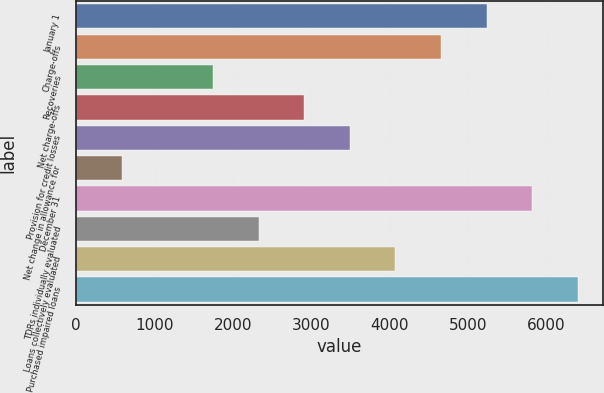Convert chart to OTSL. <chart><loc_0><loc_0><loc_500><loc_500><bar_chart><fcel>January 1<fcel>Charge-offs<fcel>Recoveries<fcel>Net charge-offs<fcel>Provision for credit losses<fcel>Net change in allowance for<fcel>December 31<fcel>TDRs individually evaluated<fcel>Loans collectively evaluated<fcel>Purchased impaired loans<nl><fcel>5233.86<fcel>4652.69<fcel>1746.84<fcel>2909.18<fcel>3490.35<fcel>584.5<fcel>5815.03<fcel>2328.01<fcel>4071.52<fcel>6396.2<nl></chart> 